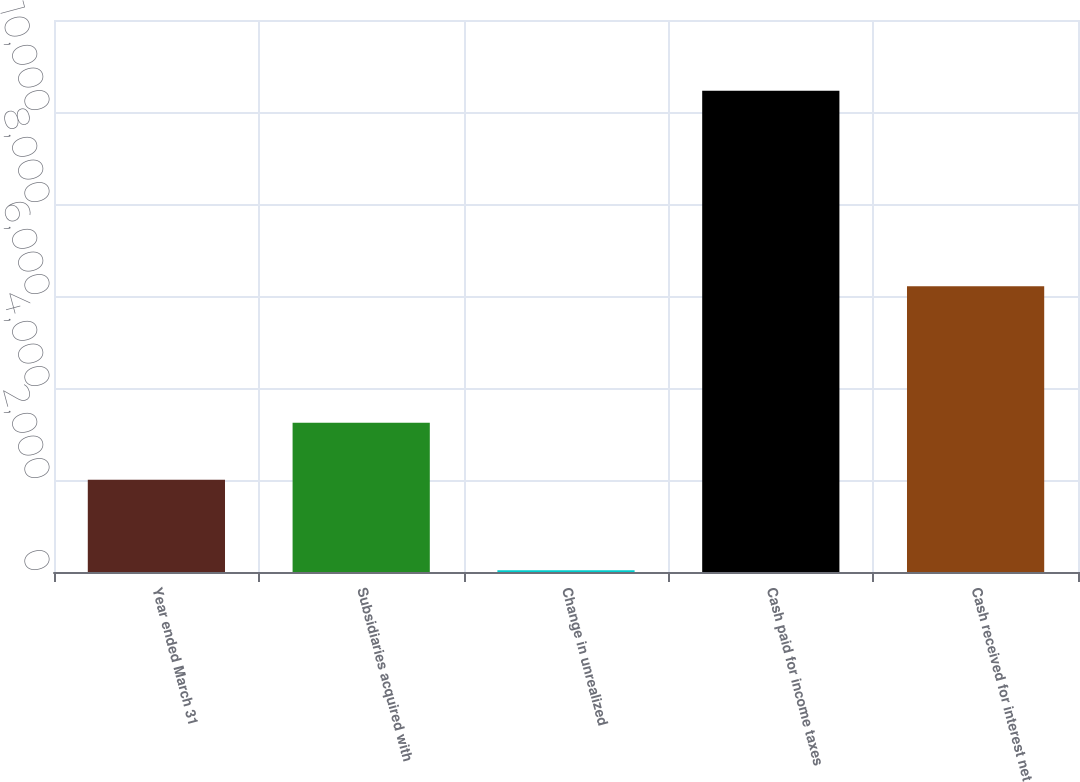<chart> <loc_0><loc_0><loc_500><loc_500><bar_chart><fcel>Year ended March 31<fcel>Subsidiaries acquired with<fcel>Change in unrealized<fcel>Cash paid for income taxes<fcel>Cash received for interest net<nl><fcel>2004<fcel>3246<fcel>37<fcel>10463<fcel>6213<nl></chart> 